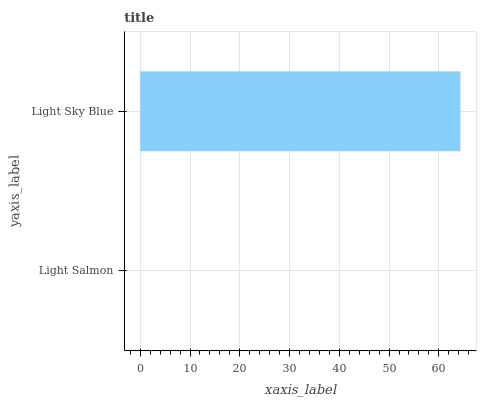Is Light Salmon the minimum?
Answer yes or no. Yes. Is Light Sky Blue the maximum?
Answer yes or no. Yes. Is Light Sky Blue the minimum?
Answer yes or no. No. Is Light Sky Blue greater than Light Salmon?
Answer yes or no. Yes. Is Light Salmon less than Light Sky Blue?
Answer yes or no. Yes. Is Light Salmon greater than Light Sky Blue?
Answer yes or no. No. Is Light Sky Blue less than Light Salmon?
Answer yes or no. No. Is Light Sky Blue the high median?
Answer yes or no. Yes. Is Light Salmon the low median?
Answer yes or no. Yes. Is Light Salmon the high median?
Answer yes or no. No. Is Light Sky Blue the low median?
Answer yes or no. No. 